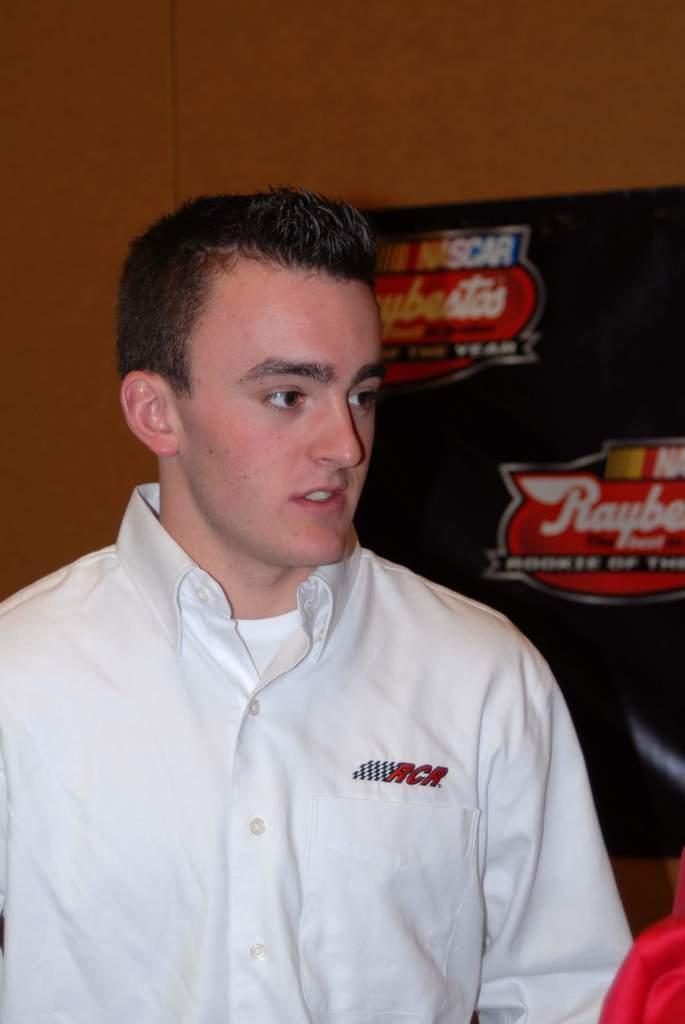<image>
Summarize the visual content of the image. An RCR employee is standing in front of board promoting Nascar. 